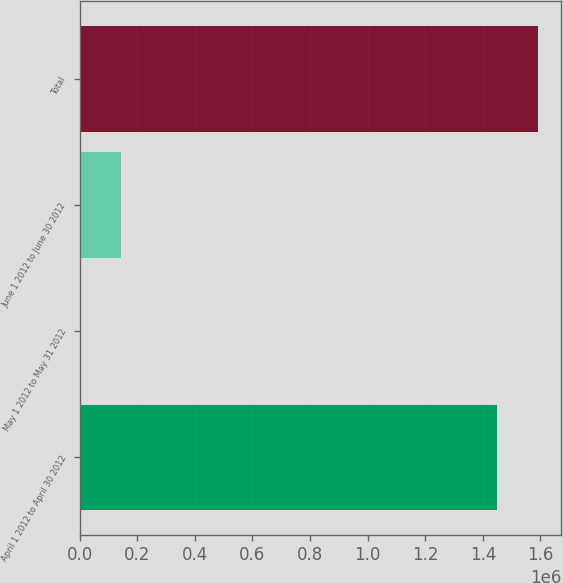Convert chart. <chart><loc_0><loc_0><loc_500><loc_500><bar_chart><fcel>April 1 2012 to April 30 2012<fcel>May 1 2012 to May 31 2012<fcel>June 1 2012 to June 30 2012<fcel>Total<nl><fcel>1.44801e+06<fcel>268<fcel>145099<fcel>1.59284e+06<nl></chart> 